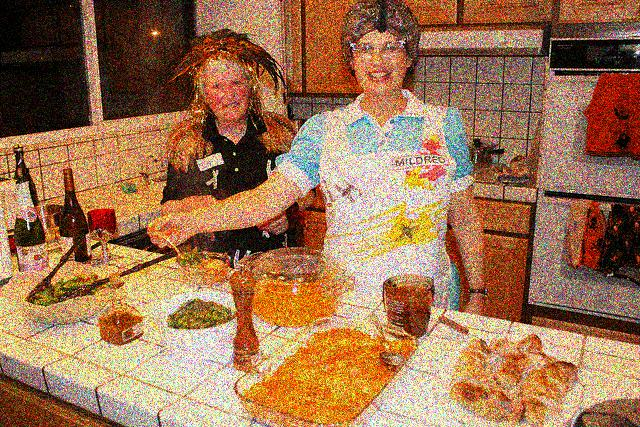Tell me about the environment the women are in. The environment appears to be a residential kitchen, evidenced by the domestic style cabinetry, tile backsplash, and various kitchen appliances visible in the background. The presence of wine bottles also suggests a relaxed, social atmosphere, which could indicate they are cooking for leisure or hosting an event. 